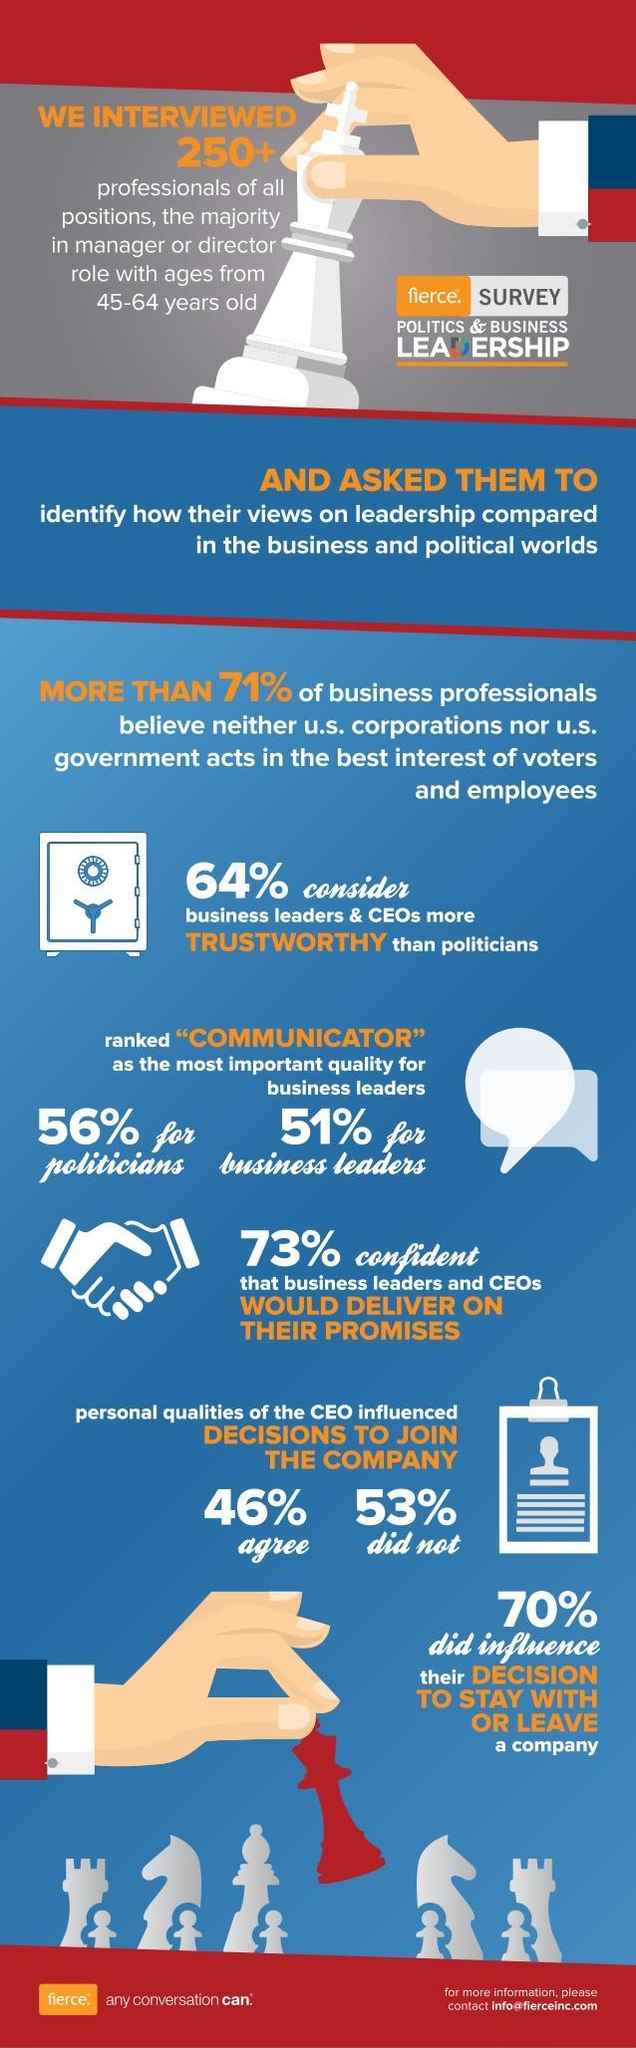Which attribute was associated as vital for both political and business leaders, trustworthiness, communication, or leadership?
Answer the question with a short phrase. communication What percentage of professionals felt that a CEO's personality influenced to them to join a company, 46%, 53%, or 70%? 46% 